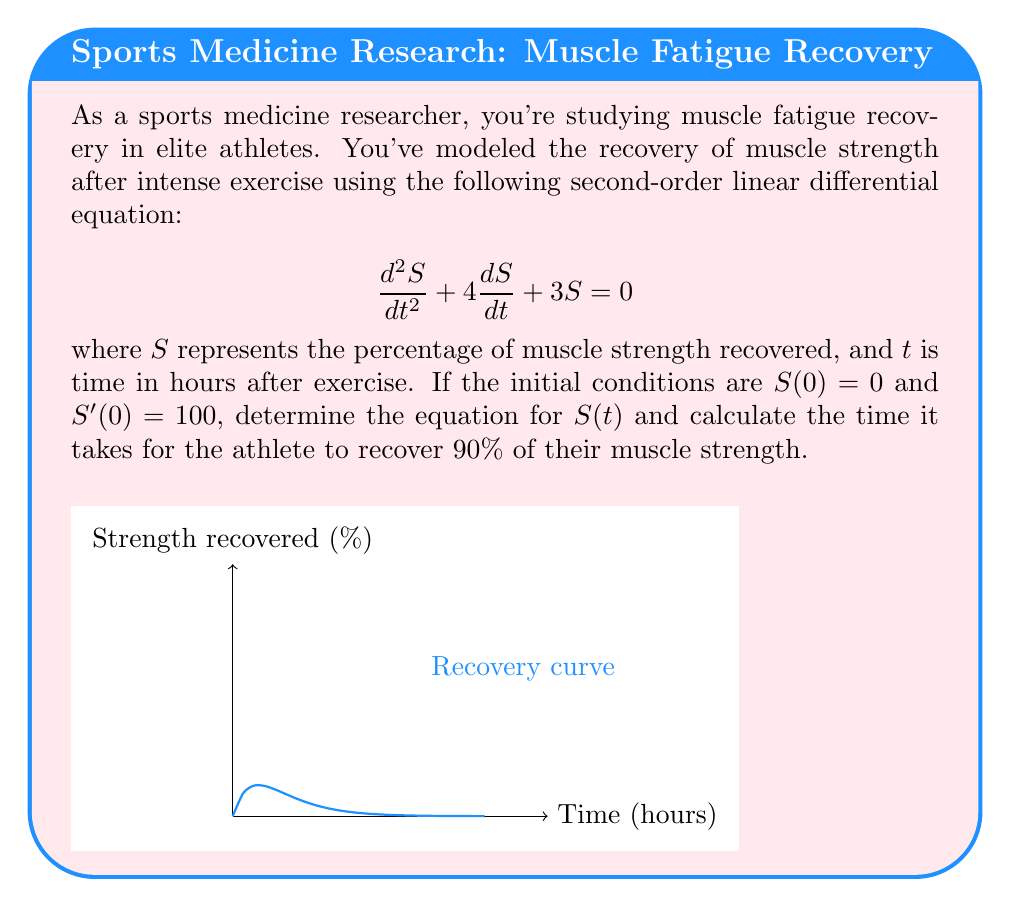Help me with this question. 1) The characteristic equation for this differential equation is:
   $$r^2 + 4r + 3 = 0$$

2) Solving this equation:
   $$r = \frac{-4 \pm \sqrt{16 - 12}}{2} = \frac{-4 \pm 2}{2}$$
   $$r_1 = -1, r_2 = -3$$

3) The general solution is:
   $$S(t) = c_1e^{-t} + c_2e^{-3t}$$

4) Using the initial condition $S(0) = 0$:
   $$0 = c_1 + c_2$$
   $$c_2 = -c_1$$

5) The derivative of $S(t)$ is:
   $$S'(t) = -c_1e^{-t} - 3c_2e^{-3t}$$

6) Using the initial condition $S'(0) = 100$:
   $$100 = -c_1 - 3c_2 = -c_1 - 3(-c_1) = 2c_1$$
   $$c_1 = 50, c_2 = -50$$

7) Therefore, the solution is:
   $$S(t) = 50e^{-t} - 50e^{-3t} = 50(e^{-t} - e^{-3t})$$

8) To find when $S(t) = 90$, we solve:
   $$90 = 50(e^{-t} - e^{-3t})$$
   $$1.8 = e^{-t} - e^{-3t}$$

9) This equation can't be solved analytically. Using numerical methods or graphing, we find:
   $$t \approx 1.54 \text{ hours}$$
Answer: $S(t) = 50(e^{-t} - e^{-3t})$; 90% recovery at $t \approx 1.54$ hours 